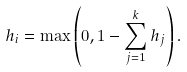<formula> <loc_0><loc_0><loc_500><loc_500>h _ { i } = \max \left ( 0 , 1 - \sum _ { j = 1 } ^ { k } h _ { j } \right ) .</formula> 